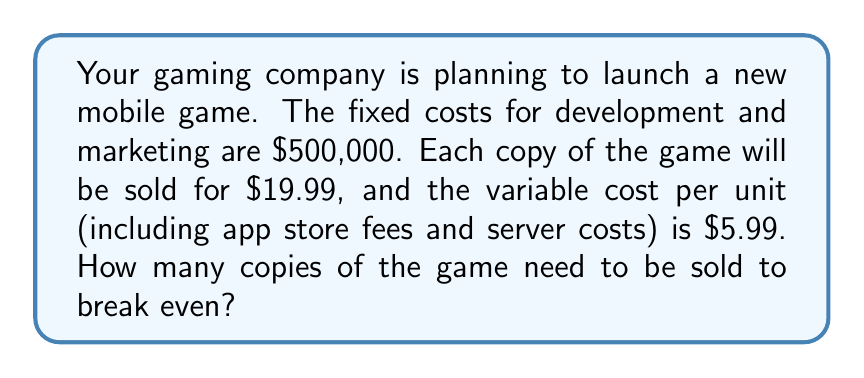Can you solve this math problem? To solve this problem, we need to use the break-even formula:

Break-even point = Fixed Costs / (Price per unit - Variable Cost per unit)

Let's plug in the values:

1. Fixed Costs (FC) = $500,000
2. Price per unit (P) = $19.99
3. Variable Cost per unit (VC) = $5.99

Break-even point = FC / (P - VC)

$$ \text{Break-even point} = \frac{\$500,000}{(\$19.99 - \$5.99)} $$

$$ = \frac{\$500,000}{\$14} $$

$$ = 35,714.29 $$

Since we can't sell a fraction of a game, we need to round up to the nearest whole number.

Therefore, the company needs to sell 35,715 copies of the game to break even.
Answer: 35,715 copies 